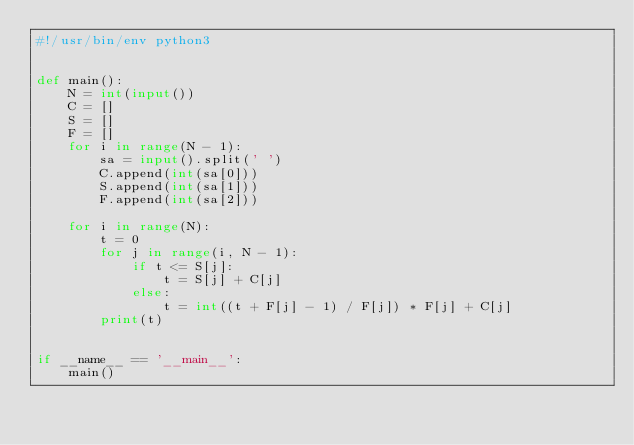Convert code to text. <code><loc_0><loc_0><loc_500><loc_500><_Python_>#!/usr/bin/env python3


def main():
    N = int(input())
    C = []
    S = []
    F = []
    for i in range(N - 1):
        sa = input().split(' ')
        C.append(int(sa[0]))
        S.append(int(sa[1]))
        F.append(int(sa[2]))

    for i in range(N):
        t = 0
        for j in range(i, N - 1):
            if t <= S[j]:
                t = S[j] + C[j]
            else:
                t = int((t + F[j] - 1) / F[j]) * F[j] + C[j]
        print(t)


if __name__ == '__main__':
    main()
</code> 